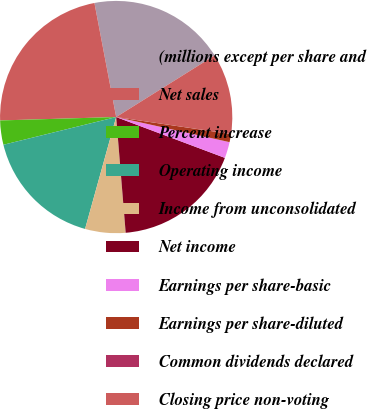Convert chart to OTSL. <chart><loc_0><loc_0><loc_500><loc_500><pie_chart><fcel>(millions except per share and<fcel>Net sales<fcel>Percent increase<fcel>Operating income<fcel>Income from unconsolidated<fcel>Net income<fcel>Earnings per share-basic<fcel>Earnings per share-diluted<fcel>Common dividends declared<fcel>Closing price non-voting<nl><fcel>19.1%<fcel>22.47%<fcel>3.37%<fcel>16.85%<fcel>5.62%<fcel>17.98%<fcel>2.25%<fcel>1.13%<fcel>0.0%<fcel>11.24%<nl></chart> 